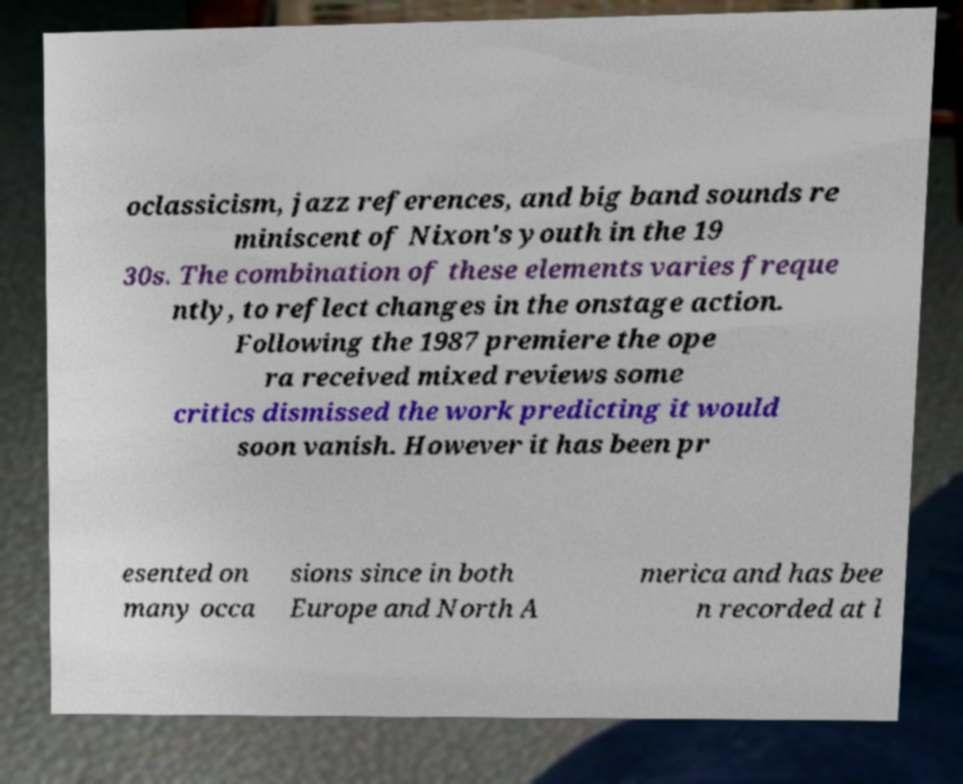Please identify and transcribe the text found in this image. oclassicism, jazz references, and big band sounds re miniscent of Nixon's youth in the 19 30s. The combination of these elements varies freque ntly, to reflect changes in the onstage action. Following the 1987 premiere the ope ra received mixed reviews some critics dismissed the work predicting it would soon vanish. However it has been pr esented on many occa sions since in both Europe and North A merica and has bee n recorded at l 